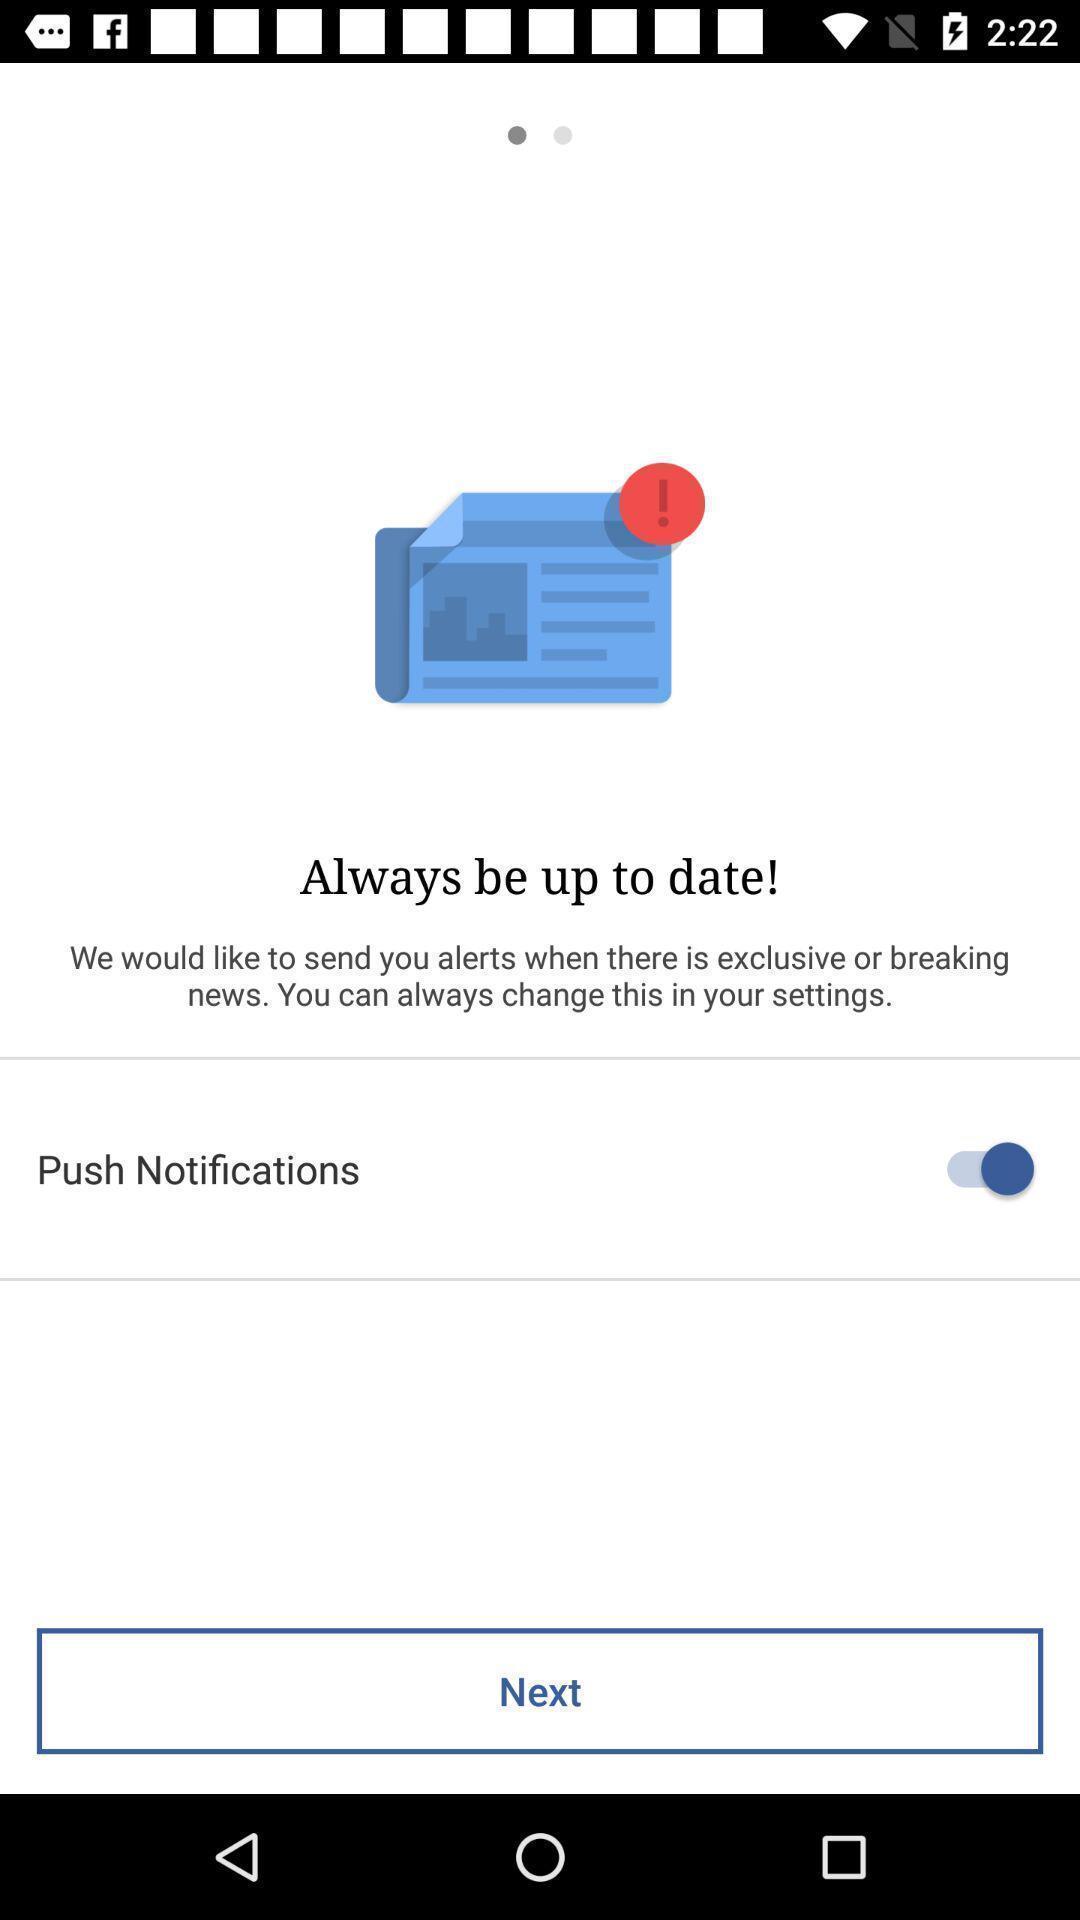Describe the visual elements of this screenshot. Start page of a weather app. 